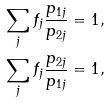Convert formula to latex. <formula><loc_0><loc_0><loc_500><loc_500>& \sum _ { j } f _ { j } \frac { p _ { 1 j } } { p _ { 2 j } } = 1 , \\ & \sum _ { j } f _ { j } \frac { p _ { 2 j } } { p _ { 1 j } } = 1 ,</formula> 